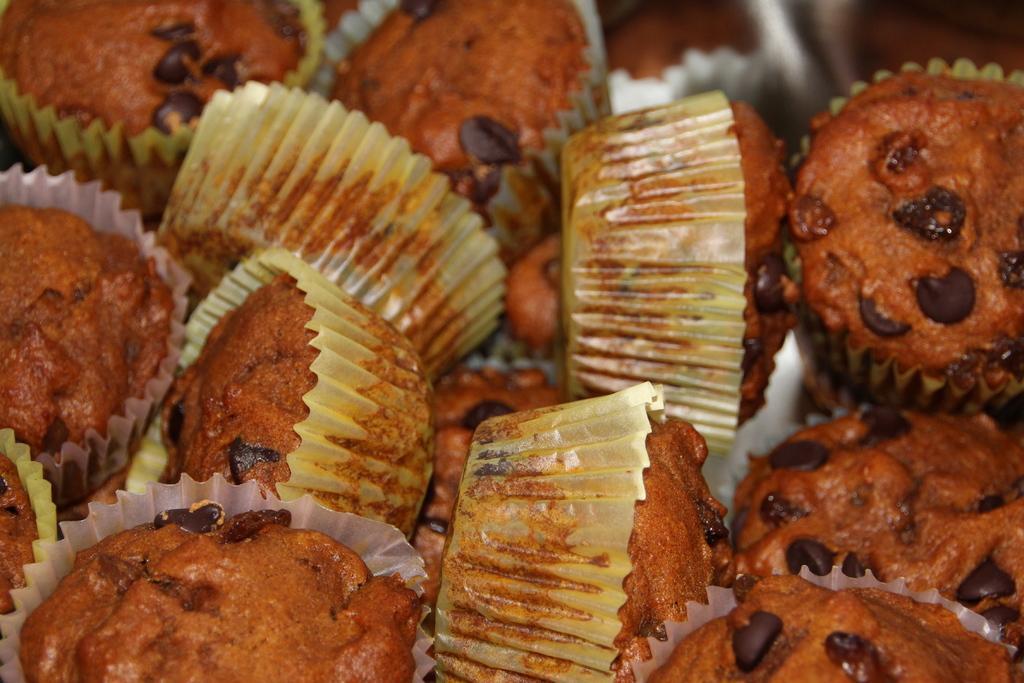Please provide a concise description of this image. In this image there are a group of cupcakes. 